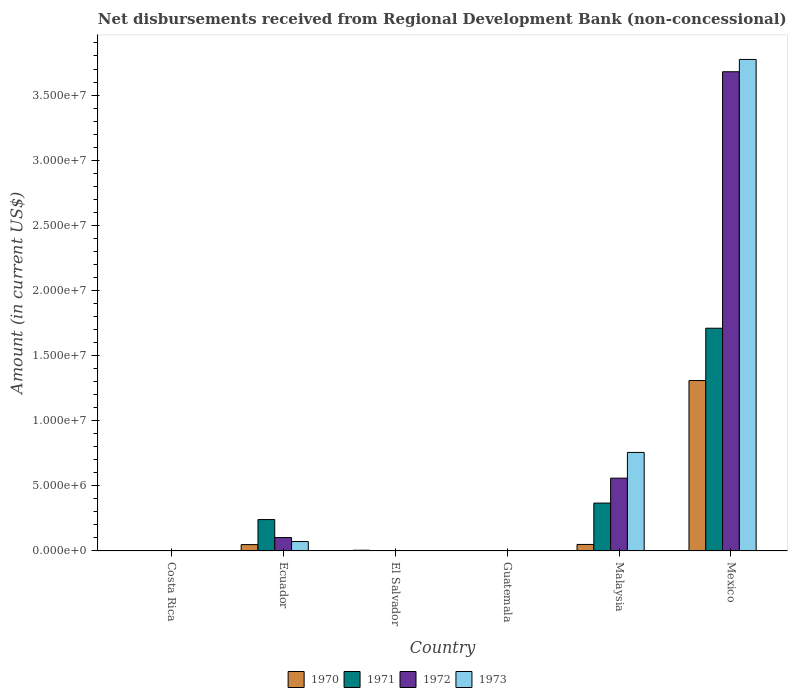How many different coloured bars are there?
Your answer should be compact. 4. How many bars are there on the 2nd tick from the left?
Offer a very short reply. 4. What is the label of the 3rd group of bars from the left?
Your response must be concise. El Salvador. What is the amount of disbursements received from Regional Development Bank in 1970 in Malaysia?
Your response must be concise. 5.02e+05. Across all countries, what is the maximum amount of disbursements received from Regional Development Bank in 1971?
Offer a very short reply. 1.71e+07. Across all countries, what is the minimum amount of disbursements received from Regional Development Bank in 1971?
Your response must be concise. 0. What is the total amount of disbursements received from Regional Development Bank in 1973 in the graph?
Your response must be concise. 4.60e+07. What is the difference between the amount of disbursements received from Regional Development Bank in 1970 in Ecuador and that in Mexico?
Give a very brief answer. -1.26e+07. What is the difference between the amount of disbursements received from Regional Development Bank in 1972 in Guatemala and the amount of disbursements received from Regional Development Bank in 1970 in Mexico?
Make the answer very short. -1.31e+07. What is the average amount of disbursements received from Regional Development Bank in 1970 per country?
Give a very brief answer. 2.36e+06. What is the difference between the amount of disbursements received from Regional Development Bank of/in 1973 and amount of disbursements received from Regional Development Bank of/in 1971 in Ecuador?
Make the answer very short. -1.68e+06. In how many countries, is the amount of disbursements received from Regional Development Bank in 1970 greater than 29000000 US$?
Make the answer very short. 0. What is the ratio of the amount of disbursements received from Regional Development Bank in 1971 in Malaysia to that in Mexico?
Give a very brief answer. 0.22. Is the amount of disbursements received from Regional Development Bank in 1973 in Ecuador less than that in Malaysia?
Keep it short and to the point. Yes. Is the difference between the amount of disbursements received from Regional Development Bank in 1973 in Ecuador and Malaysia greater than the difference between the amount of disbursements received from Regional Development Bank in 1971 in Ecuador and Malaysia?
Your response must be concise. No. What is the difference between the highest and the second highest amount of disbursements received from Regional Development Bank in 1973?
Your answer should be very brief. 3.70e+07. What is the difference between the highest and the lowest amount of disbursements received from Regional Development Bank in 1973?
Give a very brief answer. 3.77e+07. In how many countries, is the amount of disbursements received from Regional Development Bank in 1972 greater than the average amount of disbursements received from Regional Development Bank in 1972 taken over all countries?
Ensure brevity in your answer.  1. Is it the case that in every country, the sum of the amount of disbursements received from Regional Development Bank in 1972 and amount of disbursements received from Regional Development Bank in 1973 is greater than the sum of amount of disbursements received from Regional Development Bank in 1970 and amount of disbursements received from Regional Development Bank in 1971?
Your response must be concise. No. How many bars are there?
Provide a short and direct response. 13. How many legend labels are there?
Ensure brevity in your answer.  4. What is the title of the graph?
Your answer should be very brief. Net disbursements received from Regional Development Bank (non-concessional). What is the Amount (in current US$) of 1971 in Costa Rica?
Your answer should be very brief. 0. What is the Amount (in current US$) in 1972 in Costa Rica?
Offer a very short reply. 0. What is the Amount (in current US$) of 1973 in Costa Rica?
Your answer should be compact. 0. What is the Amount (in current US$) of 1970 in Ecuador?
Give a very brief answer. 4.89e+05. What is the Amount (in current US$) of 1971 in Ecuador?
Provide a short and direct response. 2.41e+06. What is the Amount (in current US$) in 1972 in Ecuador?
Provide a short and direct response. 1.03e+06. What is the Amount (in current US$) of 1973 in Ecuador?
Offer a very short reply. 7.26e+05. What is the Amount (in current US$) of 1970 in El Salvador?
Your answer should be very brief. 5.70e+04. What is the Amount (in current US$) in 1972 in El Salvador?
Provide a succinct answer. 0. What is the Amount (in current US$) in 1973 in El Salvador?
Ensure brevity in your answer.  0. What is the Amount (in current US$) in 1970 in Guatemala?
Offer a terse response. 0. What is the Amount (in current US$) in 1971 in Guatemala?
Provide a short and direct response. 0. What is the Amount (in current US$) in 1972 in Guatemala?
Make the answer very short. 0. What is the Amount (in current US$) in 1970 in Malaysia?
Your response must be concise. 5.02e+05. What is the Amount (in current US$) in 1971 in Malaysia?
Give a very brief answer. 3.68e+06. What is the Amount (in current US$) of 1972 in Malaysia?
Your response must be concise. 5.59e+06. What is the Amount (in current US$) of 1973 in Malaysia?
Provide a succinct answer. 7.57e+06. What is the Amount (in current US$) of 1970 in Mexico?
Offer a very short reply. 1.31e+07. What is the Amount (in current US$) in 1971 in Mexico?
Offer a very short reply. 1.71e+07. What is the Amount (in current US$) in 1972 in Mexico?
Your response must be concise. 3.68e+07. What is the Amount (in current US$) of 1973 in Mexico?
Ensure brevity in your answer.  3.77e+07. Across all countries, what is the maximum Amount (in current US$) in 1970?
Ensure brevity in your answer.  1.31e+07. Across all countries, what is the maximum Amount (in current US$) in 1971?
Ensure brevity in your answer.  1.71e+07. Across all countries, what is the maximum Amount (in current US$) in 1972?
Your answer should be very brief. 3.68e+07. Across all countries, what is the maximum Amount (in current US$) of 1973?
Give a very brief answer. 3.77e+07. Across all countries, what is the minimum Amount (in current US$) of 1970?
Your answer should be compact. 0. Across all countries, what is the minimum Amount (in current US$) of 1971?
Your answer should be compact. 0. Across all countries, what is the minimum Amount (in current US$) in 1972?
Give a very brief answer. 0. Across all countries, what is the minimum Amount (in current US$) of 1973?
Keep it short and to the point. 0. What is the total Amount (in current US$) of 1970 in the graph?
Make the answer very short. 1.41e+07. What is the total Amount (in current US$) in 1971 in the graph?
Your answer should be very brief. 2.32e+07. What is the total Amount (in current US$) of 1972 in the graph?
Your answer should be compact. 4.34e+07. What is the total Amount (in current US$) of 1973 in the graph?
Your response must be concise. 4.60e+07. What is the difference between the Amount (in current US$) of 1970 in Ecuador and that in El Salvador?
Give a very brief answer. 4.32e+05. What is the difference between the Amount (in current US$) in 1970 in Ecuador and that in Malaysia?
Provide a succinct answer. -1.30e+04. What is the difference between the Amount (in current US$) in 1971 in Ecuador and that in Malaysia?
Offer a very short reply. -1.27e+06. What is the difference between the Amount (in current US$) in 1972 in Ecuador and that in Malaysia?
Provide a succinct answer. -4.56e+06. What is the difference between the Amount (in current US$) in 1973 in Ecuador and that in Malaysia?
Give a very brief answer. -6.84e+06. What is the difference between the Amount (in current US$) in 1970 in Ecuador and that in Mexico?
Keep it short and to the point. -1.26e+07. What is the difference between the Amount (in current US$) of 1971 in Ecuador and that in Mexico?
Your answer should be compact. -1.47e+07. What is the difference between the Amount (in current US$) in 1972 in Ecuador and that in Mexico?
Ensure brevity in your answer.  -3.58e+07. What is the difference between the Amount (in current US$) in 1973 in Ecuador and that in Mexico?
Give a very brief answer. -3.70e+07. What is the difference between the Amount (in current US$) of 1970 in El Salvador and that in Malaysia?
Keep it short and to the point. -4.45e+05. What is the difference between the Amount (in current US$) of 1970 in El Salvador and that in Mexico?
Provide a succinct answer. -1.30e+07. What is the difference between the Amount (in current US$) of 1970 in Malaysia and that in Mexico?
Give a very brief answer. -1.26e+07. What is the difference between the Amount (in current US$) in 1971 in Malaysia and that in Mexico?
Your answer should be very brief. -1.34e+07. What is the difference between the Amount (in current US$) in 1972 in Malaysia and that in Mexico?
Your answer should be very brief. -3.12e+07. What is the difference between the Amount (in current US$) in 1973 in Malaysia and that in Mexico?
Give a very brief answer. -3.02e+07. What is the difference between the Amount (in current US$) in 1970 in Ecuador and the Amount (in current US$) in 1971 in Malaysia?
Provide a short and direct response. -3.19e+06. What is the difference between the Amount (in current US$) of 1970 in Ecuador and the Amount (in current US$) of 1972 in Malaysia?
Keep it short and to the point. -5.10e+06. What is the difference between the Amount (in current US$) of 1970 in Ecuador and the Amount (in current US$) of 1973 in Malaysia?
Offer a very short reply. -7.08e+06. What is the difference between the Amount (in current US$) of 1971 in Ecuador and the Amount (in current US$) of 1972 in Malaysia?
Give a very brief answer. -3.18e+06. What is the difference between the Amount (in current US$) of 1971 in Ecuador and the Amount (in current US$) of 1973 in Malaysia?
Your answer should be compact. -5.16e+06. What is the difference between the Amount (in current US$) in 1972 in Ecuador and the Amount (in current US$) in 1973 in Malaysia?
Give a very brief answer. -6.54e+06. What is the difference between the Amount (in current US$) of 1970 in Ecuador and the Amount (in current US$) of 1971 in Mexico?
Ensure brevity in your answer.  -1.66e+07. What is the difference between the Amount (in current US$) in 1970 in Ecuador and the Amount (in current US$) in 1972 in Mexico?
Offer a very short reply. -3.63e+07. What is the difference between the Amount (in current US$) in 1970 in Ecuador and the Amount (in current US$) in 1973 in Mexico?
Provide a short and direct response. -3.72e+07. What is the difference between the Amount (in current US$) of 1971 in Ecuador and the Amount (in current US$) of 1972 in Mexico?
Offer a very short reply. -3.44e+07. What is the difference between the Amount (in current US$) in 1971 in Ecuador and the Amount (in current US$) in 1973 in Mexico?
Your response must be concise. -3.53e+07. What is the difference between the Amount (in current US$) of 1972 in Ecuador and the Amount (in current US$) of 1973 in Mexico?
Your answer should be compact. -3.67e+07. What is the difference between the Amount (in current US$) in 1970 in El Salvador and the Amount (in current US$) in 1971 in Malaysia?
Give a very brief answer. -3.62e+06. What is the difference between the Amount (in current US$) in 1970 in El Salvador and the Amount (in current US$) in 1972 in Malaysia?
Your response must be concise. -5.53e+06. What is the difference between the Amount (in current US$) in 1970 in El Salvador and the Amount (in current US$) in 1973 in Malaysia?
Your answer should be very brief. -7.51e+06. What is the difference between the Amount (in current US$) in 1970 in El Salvador and the Amount (in current US$) in 1971 in Mexico?
Offer a very short reply. -1.70e+07. What is the difference between the Amount (in current US$) of 1970 in El Salvador and the Amount (in current US$) of 1972 in Mexico?
Your response must be concise. -3.67e+07. What is the difference between the Amount (in current US$) of 1970 in El Salvador and the Amount (in current US$) of 1973 in Mexico?
Your answer should be very brief. -3.77e+07. What is the difference between the Amount (in current US$) of 1970 in Malaysia and the Amount (in current US$) of 1971 in Mexico?
Provide a succinct answer. -1.66e+07. What is the difference between the Amount (in current US$) in 1970 in Malaysia and the Amount (in current US$) in 1972 in Mexico?
Your answer should be compact. -3.63e+07. What is the difference between the Amount (in current US$) in 1970 in Malaysia and the Amount (in current US$) in 1973 in Mexico?
Offer a very short reply. -3.72e+07. What is the difference between the Amount (in current US$) in 1971 in Malaysia and the Amount (in current US$) in 1972 in Mexico?
Ensure brevity in your answer.  -3.31e+07. What is the difference between the Amount (in current US$) of 1971 in Malaysia and the Amount (in current US$) of 1973 in Mexico?
Provide a short and direct response. -3.41e+07. What is the difference between the Amount (in current US$) of 1972 in Malaysia and the Amount (in current US$) of 1973 in Mexico?
Provide a short and direct response. -3.21e+07. What is the average Amount (in current US$) of 1970 per country?
Your answer should be very brief. 2.36e+06. What is the average Amount (in current US$) in 1971 per country?
Offer a terse response. 3.86e+06. What is the average Amount (in current US$) of 1972 per country?
Give a very brief answer. 7.24e+06. What is the average Amount (in current US$) of 1973 per country?
Provide a succinct answer. 7.67e+06. What is the difference between the Amount (in current US$) of 1970 and Amount (in current US$) of 1971 in Ecuador?
Offer a very short reply. -1.92e+06. What is the difference between the Amount (in current US$) of 1970 and Amount (in current US$) of 1972 in Ecuador?
Offer a terse response. -5.42e+05. What is the difference between the Amount (in current US$) in 1970 and Amount (in current US$) in 1973 in Ecuador?
Provide a succinct answer. -2.37e+05. What is the difference between the Amount (in current US$) in 1971 and Amount (in current US$) in 1972 in Ecuador?
Make the answer very short. 1.38e+06. What is the difference between the Amount (in current US$) of 1971 and Amount (in current US$) of 1973 in Ecuador?
Make the answer very short. 1.68e+06. What is the difference between the Amount (in current US$) of 1972 and Amount (in current US$) of 1973 in Ecuador?
Your answer should be compact. 3.05e+05. What is the difference between the Amount (in current US$) in 1970 and Amount (in current US$) in 1971 in Malaysia?
Make the answer very short. -3.18e+06. What is the difference between the Amount (in current US$) of 1970 and Amount (in current US$) of 1972 in Malaysia?
Your response must be concise. -5.09e+06. What is the difference between the Amount (in current US$) in 1970 and Amount (in current US$) in 1973 in Malaysia?
Keep it short and to the point. -7.06e+06. What is the difference between the Amount (in current US$) of 1971 and Amount (in current US$) of 1972 in Malaysia?
Make the answer very short. -1.91e+06. What is the difference between the Amount (in current US$) in 1971 and Amount (in current US$) in 1973 in Malaysia?
Your response must be concise. -3.89e+06. What is the difference between the Amount (in current US$) in 1972 and Amount (in current US$) in 1973 in Malaysia?
Make the answer very short. -1.98e+06. What is the difference between the Amount (in current US$) of 1970 and Amount (in current US$) of 1971 in Mexico?
Keep it short and to the point. -4.02e+06. What is the difference between the Amount (in current US$) in 1970 and Amount (in current US$) in 1972 in Mexico?
Offer a very short reply. -2.37e+07. What is the difference between the Amount (in current US$) of 1970 and Amount (in current US$) of 1973 in Mexico?
Keep it short and to the point. -2.46e+07. What is the difference between the Amount (in current US$) in 1971 and Amount (in current US$) in 1972 in Mexico?
Your answer should be very brief. -1.97e+07. What is the difference between the Amount (in current US$) in 1971 and Amount (in current US$) in 1973 in Mexico?
Keep it short and to the point. -2.06e+07. What is the difference between the Amount (in current US$) in 1972 and Amount (in current US$) in 1973 in Mexico?
Your answer should be compact. -9.43e+05. What is the ratio of the Amount (in current US$) of 1970 in Ecuador to that in El Salvador?
Offer a very short reply. 8.58. What is the ratio of the Amount (in current US$) of 1970 in Ecuador to that in Malaysia?
Keep it short and to the point. 0.97. What is the ratio of the Amount (in current US$) of 1971 in Ecuador to that in Malaysia?
Your answer should be very brief. 0.66. What is the ratio of the Amount (in current US$) of 1972 in Ecuador to that in Malaysia?
Offer a very short reply. 0.18. What is the ratio of the Amount (in current US$) in 1973 in Ecuador to that in Malaysia?
Offer a terse response. 0.1. What is the ratio of the Amount (in current US$) of 1970 in Ecuador to that in Mexico?
Your answer should be compact. 0.04. What is the ratio of the Amount (in current US$) of 1971 in Ecuador to that in Mexico?
Provide a succinct answer. 0.14. What is the ratio of the Amount (in current US$) in 1972 in Ecuador to that in Mexico?
Give a very brief answer. 0.03. What is the ratio of the Amount (in current US$) of 1973 in Ecuador to that in Mexico?
Give a very brief answer. 0.02. What is the ratio of the Amount (in current US$) in 1970 in El Salvador to that in Malaysia?
Provide a short and direct response. 0.11. What is the ratio of the Amount (in current US$) in 1970 in El Salvador to that in Mexico?
Provide a short and direct response. 0. What is the ratio of the Amount (in current US$) in 1970 in Malaysia to that in Mexico?
Keep it short and to the point. 0.04. What is the ratio of the Amount (in current US$) of 1971 in Malaysia to that in Mexico?
Offer a terse response. 0.21. What is the ratio of the Amount (in current US$) of 1972 in Malaysia to that in Mexico?
Offer a very short reply. 0.15. What is the ratio of the Amount (in current US$) in 1973 in Malaysia to that in Mexico?
Give a very brief answer. 0.2. What is the difference between the highest and the second highest Amount (in current US$) in 1970?
Keep it short and to the point. 1.26e+07. What is the difference between the highest and the second highest Amount (in current US$) of 1971?
Keep it short and to the point. 1.34e+07. What is the difference between the highest and the second highest Amount (in current US$) in 1972?
Keep it short and to the point. 3.12e+07. What is the difference between the highest and the second highest Amount (in current US$) in 1973?
Give a very brief answer. 3.02e+07. What is the difference between the highest and the lowest Amount (in current US$) of 1970?
Provide a succinct answer. 1.31e+07. What is the difference between the highest and the lowest Amount (in current US$) in 1971?
Keep it short and to the point. 1.71e+07. What is the difference between the highest and the lowest Amount (in current US$) of 1972?
Provide a succinct answer. 3.68e+07. What is the difference between the highest and the lowest Amount (in current US$) of 1973?
Your answer should be very brief. 3.77e+07. 